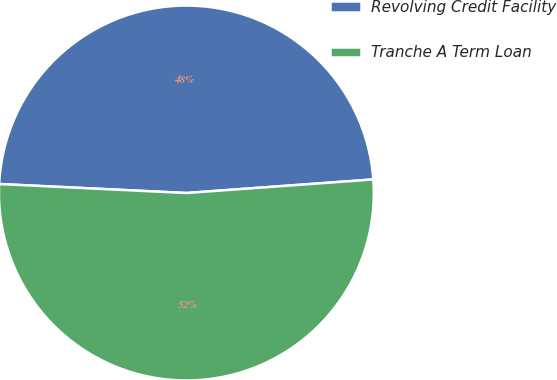<chart> <loc_0><loc_0><loc_500><loc_500><pie_chart><fcel>Revolving Credit Facility<fcel>Tranche A Term Loan<nl><fcel>48.08%<fcel>51.92%<nl></chart> 